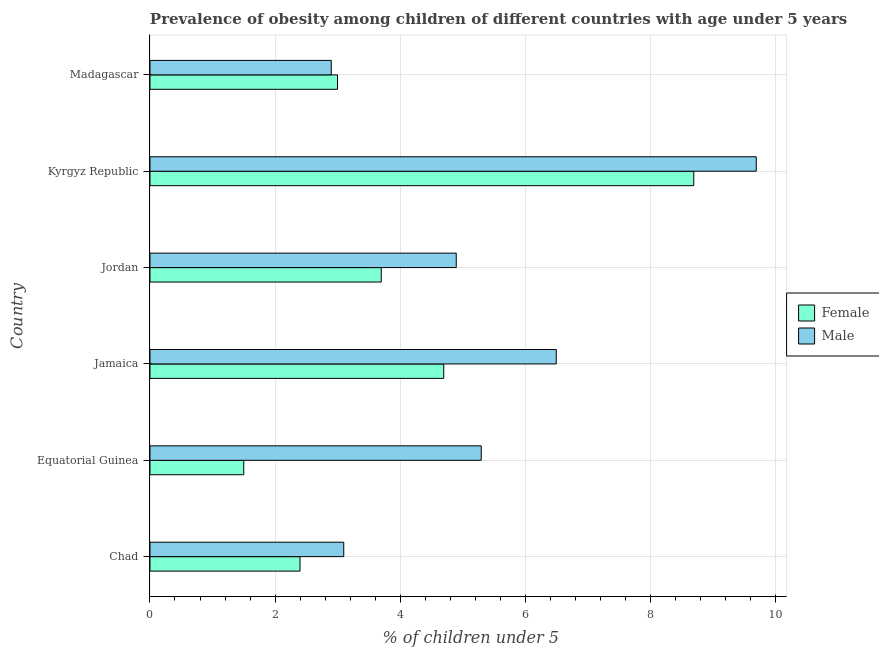How many different coloured bars are there?
Offer a very short reply. 2. How many groups of bars are there?
Your answer should be compact. 6. Are the number of bars per tick equal to the number of legend labels?
Your answer should be very brief. Yes. What is the label of the 3rd group of bars from the top?
Your response must be concise. Jordan. What is the percentage of obese male children in Equatorial Guinea?
Ensure brevity in your answer.  5.3. Across all countries, what is the maximum percentage of obese male children?
Give a very brief answer. 9.7. Across all countries, what is the minimum percentage of obese male children?
Offer a very short reply. 2.9. In which country was the percentage of obese female children maximum?
Your answer should be compact. Kyrgyz Republic. In which country was the percentage of obese female children minimum?
Offer a very short reply. Equatorial Guinea. What is the total percentage of obese female children in the graph?
Provide a short and direct response. 24. What is the difference between the percentage of obese male children in Chad and that in Jamaica?
Give a very brief answer. -3.4. What is the difference between the percentage of obese male children in Chad and the percentage of obese female children in Jordan?
Make the answer very short. -0.6. What is the difference between the percentage of obese male children and percentage of obese female children in Kyrgyz Republic?
Make the answer very short. 1. In how many countries, is the percentage of obese male children greater than 4.4 %?
Offer a very short reply. 4. What is the ratio of the percentage of obese female children in Jamaica to that in Madagascar?
Ensure brevity in your answer.  1.57. What is the difference between the highest and the second highest percentage of obese male children?
Ensure brevity in your answer.  3.2. Is the sum of the percentage of obese male children in Jamaica and Madagascar greater than the maximum percentage of obese female children across all countries?
Provide a short and direct response. Yes. What does the 2nd bar from the bottom in Equatorial Guinea represents?
Offer a terse response. Male. How many bars are there?
Your answer should be compact. 12. How many countries are there in the graph?
Provide a short and direct response. 6. What is the difference between two consecutive major ticks on the X-axis?
Provide a succinct answer. 2. Does the graph contain any zero values?
Provide a short and direct response. No. Does the graph contain grids?
Offer a terse response. Yes. Where does the legend appear in the graph?
Offer a terse response. Center right. How many legend labels are there?
Ensure brevity in your answer.  2. How are the legend labels stacked?
Give a very brief answer. Vertical. What is the title of the graph?
Your answer should be compact. Prevalence of obesity among children of different countries with age under 5 years. Does "Private funds" appear as one of the legend labels in the graph?
Give a very brief answer. No. What is the label or title of the X-axis?
Give a very brief answer.  % of children under 5. What is the label or title of the Y-axis?
Offer a terse response. Country. What is the  % of children under 5 in Female in Chad?
Your response must be concise. 2.4. What is the  % of children under 5 of Male in Chad?
Offer a terse response. 3.1. What is the  % of children under 5 in Male in Equatorial Guinea?
Make the answer very short. 5.3. What is the  % of children under 5 in Female in Jamaica?
Your answer should be very brief. 4.7. What is the  % of children under 5 of Female in Jordan?
Keep it short and to the point. 3.7. What is the  % of children under 5 of Male in Jordan?
Your response must be concise. 4.9. What is the  % of children under 5 of Female in Kyrgyz Republic?
Keep it short and to the point. 8.7. What is the  % of children under 5 in Male in Kyrgyz Republic?
Your answer should be compact. 9.7. What is the  % of children under 5 of Female in Madagascar?
Keep it short and to the point. 3. What is the  % of children under 5 of Male in Madagascar?
Your answer should be compact. 2.9. Across all countries, what is the maximum  % of children under 5 of Female?
Ensure brevity in your answer.  8.7. Across all countries, what is the maximum  % of children under 5 in Male?
Offer a very short reply. 9.7. Across all countries, what is the minimum  % of children under 5 of Male?
Your answer should be very brief. 2.9. What is the total  % of children under 5 in Female in the graph?
Your answer should be compact. 24. What is the total  % of children under 5 in Male in the graph?
Your response must be concise. 32.4. What is the difference between the  % of children under 5 in Female in Chad and that in Jamaica?
Give a very brief answer. -2.3. What is the difference between the  % of children under 5 in Male in Chad and that in Jamaica?
Your response must be concise. -3.4. What is the difference between the  % of children under 5 of Female in Chad and that in Jordan?
Your response must be concise. -1.3. What is the difference between the  % of children under 5 in Male in Chad and that in Madagascar?
Your answer should be compact. 0.2. What is the difference between the  % of children under 5 in Female in Equatorial Guinea and that in Jamaica?
Offer a very short reply. -3.2. What is the difference between the  % of children under 5 of Male in Equatorial Guinea and that in Jordan?
Your answer should be compact. 0.4. What is the difference between the  % of children under 5 in Female in Equatorial Guinea and that in Kyrgyz Republic?
Ensure brevity in your answer.  -7.2. What is the difference between the  % of children under 5 in Female in Jamaica and that in Jordan?
Offer a terse response. 1. What is the difference between the  % of children under 5 of Male in Jamaica and that in Jordan?
Offer a terse response. 1.6. What is the difference between the  % of children under 5 of Male in Jamaica and that in Madagascar?
Keep it short and to the point. 3.6. What is the difference between the  % of children under 5 in Male in Jordan and that in Kyrgyz Republic?
Offer a terse response. -4.8. What is the difference between the  % of children under 5 in Female in Jordan and that in Madagascar?
Provide a succinct answer. 0.7. What is the difference between the  % of children under 5 of Male in Jordan and that in Madagascar?
Offer a very short reply. 2. What is the difference between the  % of children under 5 in Female in Kyrgyz Republic and that in Madagascar?
Provide a short and direct response. 5.7. What is the difference between the  % of children under 5 in Male in Kyrgyz Republic and that in Madagascar?
Offer a very short reply. 6.8. What is the difference between the  % of children under 5 in Female in Chad and the  % of children under 5 in Male in Equatorial Guinea?
Offer a terse response. -2.9. What is the difference between the  % of children under 5 of Female in Chad and the  % of children under 5 of Male in Jordan?
Provide a short and direct response. -2.5. What is the difference between the  % of children under 5 in Female in Chad and the  % of children under 5 in Male in Kyrgyz Republic?
Ensure brevity in your answer.  -7.3. What is the difference between the  % of children under 5 in Female in Equatorial Guinea and the  % of children under 5 in Male in Jamaica?
Provide a short and direct response. -5. What is the difference between the  % of children under 5 in Female in Equatorial Guinea and the  % of children under 5 in Male in Madagascar?
Ensure brevity in your answer.  -1.4. What is the difference between the  % of children under 5 in Female in Jamaica and the  % of children under 5 in Male in Jordan?
Offer a terse response. -0.2. What is the difference between the  % of children under 5 in Female in Jamaica and the  % of children under 5 in Male in Kyrgyz Republic?
Your answer should be compact. -5. What is the difference between the  % of children under 5 of Female in Jordan and the  % of children under 5 of Male in Kyrgyz Republic?
Your answer should be compact. -6. What is the average  % of children under 5 of Male per country?
Provide a succinct answer. 5.4. What is the difference between the  % of children under 5 in Female and  % of children under 5 in Male in Kyrgyz Republic?
Offer a very short reply. -1. What is the ratio of the  % of children under 5 of Female in Chad to that in Equatorial Guinea?
Your response must be concise. 1.6. What is the ratio of the  % of children under 5 in Male in Chad to that in Equatorial Guinea?
Provide a succinct answer. 0.58. What is the ratio of the  % of children under 5 of Female in Chad to that in Jamaica?
Offer a very short reply. 0.51. What is the ratio of the  % of children under 5 of Male in Chad to that in Jamaica?
Your answer should be very brief. 0.48. What is the ratio of the  % of children under 5 in Female in Chad to that in Jordan?
Make the answer very short. 0.65. What is the ratio of the  % of children under 5 in Male in Chad to that in Jordan?
Your response must be concise. 0.63. What is the ratio of the  % of children under 5 in Female in Chad to that in Kyrgyz Republic?
Your answer should be compact. 0.28. What is the ratio of the  % of children under 5 in Male in Chad to that in Kyrgyz Republic?
Your answer should be very brief. 0.32. What is the ratio of the  % of children under 5 of Male in Chad to that in Madagascar?
Keep it short and to the point. 1.07. What is the ratio of the  % of children under 5 in Female in Equatorial Guinea to that in Jamaica?
Your answer should be compact. 0.32. What is the ratio of the  % of children under 5 of Male in Equatorial Guinea to that in Jamaica?
Offer a very short reply. 0.82. What is the ratio of the  % of children under 5 of Female in Equatorial Guinea to that in Jordan?
Offer a terse response. 0.41. What is the ratio of the  % of children under 5 in Male in Equatorial Guinea to that in Jordan?
Offer a terse response. 1.08. What is the ratio of the  % of children under 5 of Female in Equatorial Guinea to that in Kyrgyz Republic?
Provide a succinct answer. 0.17. What is the ratio of the  % of children under 5 in Male in Equatorial Guinea to that in Kyrgyz Republic?
Offer a very short reply. 0.55. What is the ratio of the  % of children under 5 in Male in Equatorial Guinea to that in Madagascar?
Your answer should be compact. 1.83. What is the ratio of the  % of children under 5 in Female in Jamaica to that in Jordan?
Offer a very short reply. 1.27. What is the ratio of the  % of children under 5 of Male in Jamaica to that in Jordan?
Your answer should be compact. 1.33. What is the ratio of the  % of children under 5 in Female in Jamaica to that in Kyrgyz Republic?
Your answer should be compact. 0.54. What is the ratio of the  % of children under 5 of Male in Jamaica to that in Kyrgyz Republic?
Provide a succinct answer. 0.67. What is the ratio of the  % of children under 5 of Female in Jamaica to that in Madagascar?
Give a very brief answer. 1.57. What is the ratio of the  % of children under 5 in Male in Jamaica to that in Madagascar?
Your response must be concise. 2.24. What is the ratio of the  % of children under 5 of Female in Jordan to that in Kyrgyz Republic?
Your response must be concise. 0.43. What is the ratio of the  % of children under 5 of Male in Jordan to that in Kyrgyz Republic?
Your answer should be compact. 0.51. What is the ratio of the  % of children under 5 in Female in Jordan to that in Madagascar?
Make the answer very short. 1.23. What is the ratio of the  % of children under 5 in Male in Jordan to that in Madagascar?
Provide a short and direct response. 1.69. What is the ratio of the  % of children under 5 in Female in Kyrgyz Republic to that in Madagascar?
Give a very brief answer. 2.9. What is the ratio of the  % of children under 5 of Male in Kyrgyz Republic to that in Madagascar?
Give a very brief answer. 3.34. What is the difference between the highest and the second highest  % of children under 5 of Female?
Provide a short and direct response. 4. 